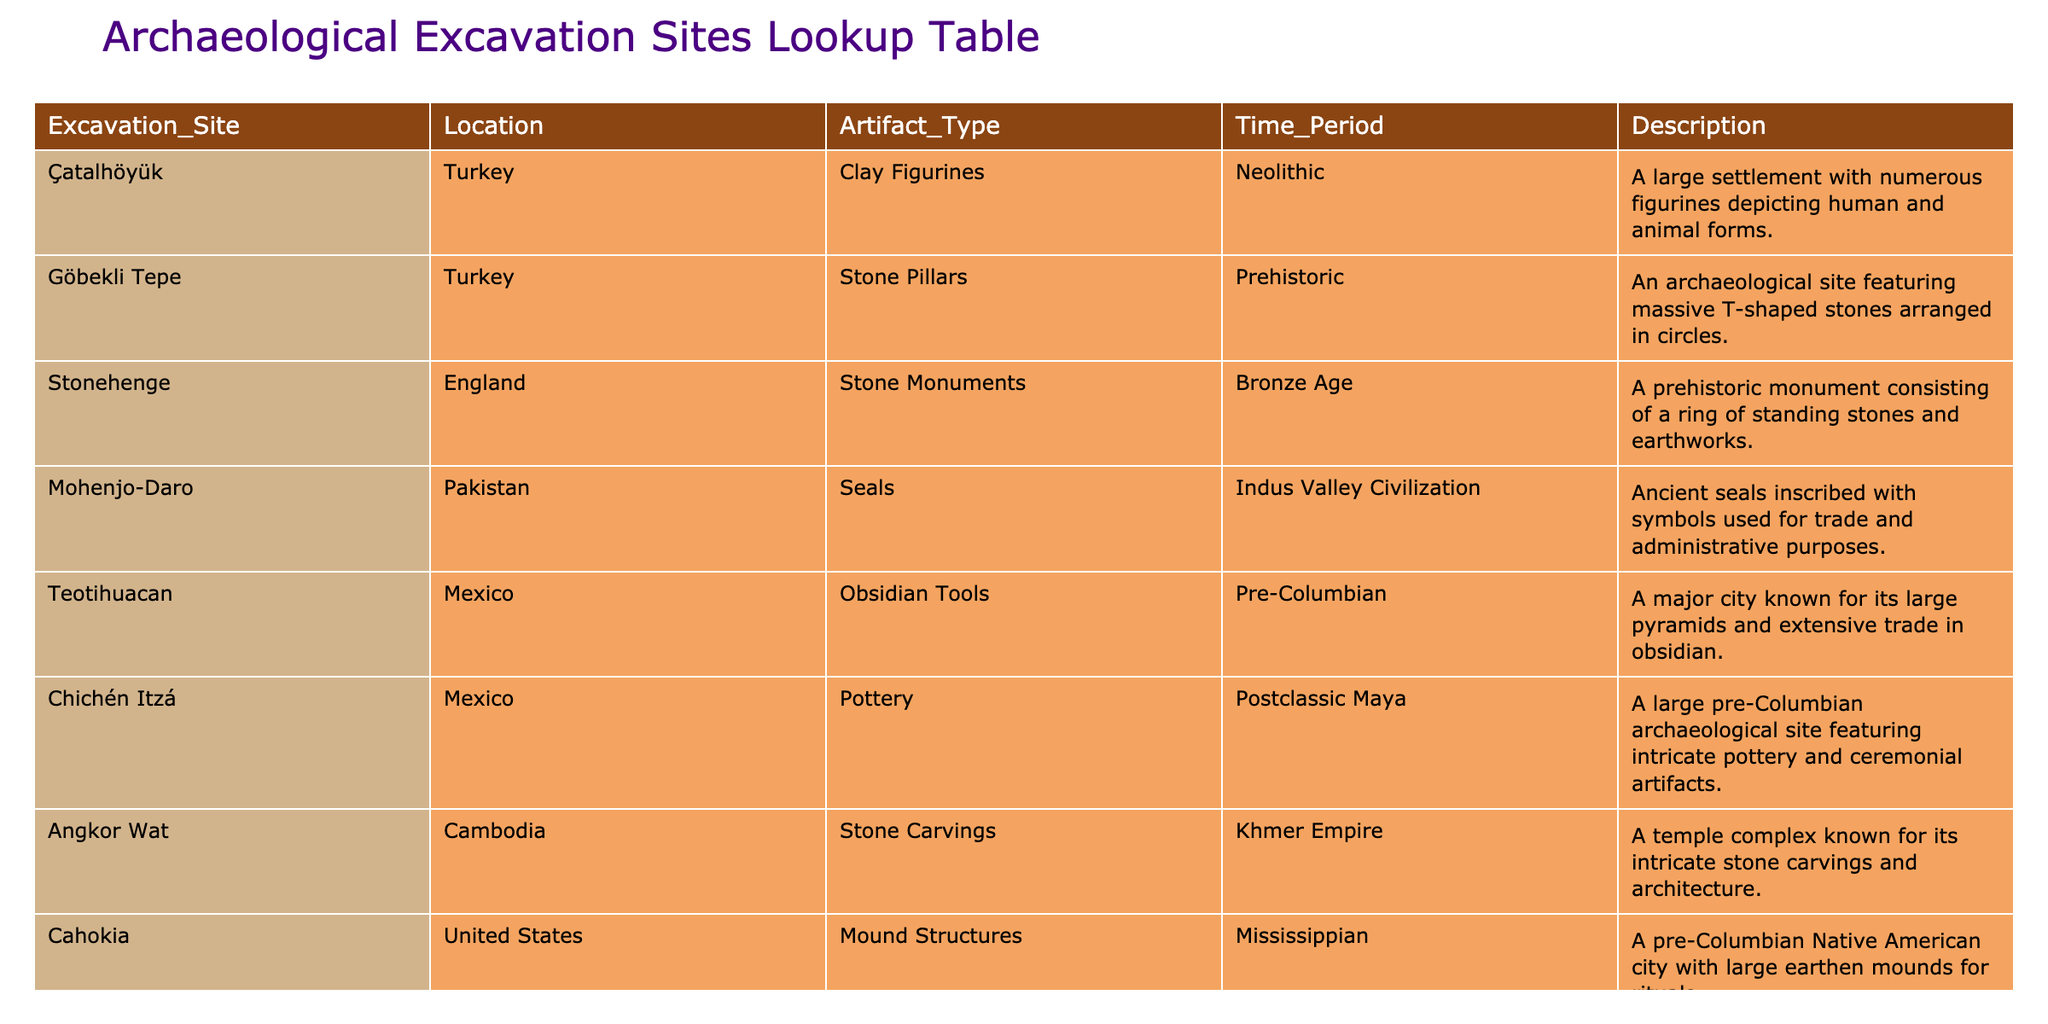What artifact type is found at Çatalhöyük? The table entry for Çatalhöyük indicates that the artifact type is Clay Figurines.
Answer: Clay Figurines Which location is associated with Stone Pillars? The table shows that Göbekli Tepe is the location associated with Stone Pillars.
Answer: Göbekli Tepe How many artifact types are listed for excavation sites in Mexico? The table lists two artifact types from Mexican excavation sites: Obsidian Tools at Teotihuacan and Pottery at Chichén Itzá. Therefore, the count is 2.
Answer: 2 True or False: Mesa Verde is known for its stone carvings. The table specifically states that Mesa Verde is known for Cliff Dwellings, not stone carvings. Therefore, the statement is false.
Answer: False What is the time period for artifacts found at Angkor Wat? According to the table, Angkor Wat's artifact type is from the Khmer Empire, indicating the corresponding time period.
Answer: Khmer Empire Which excavation site has the earliest time period indicated in the table? Göbekli Tepe is the earliest site listed, categorized as Prehistoric, whereas others fall into later periods like Neolithic, Bronze Age, etc.
Answer: Göbekli Tepe What type of artifacts can be found at Mohenjo-Daro? The table specifies that the artifacts from Mohenjo-Daro are Seals.
Answer: Seals What are the total number of excavation sites listed in the table that are situated in the United States? The table indicates two sites: Cahokia and Mesa Verde, both located in the United States, resulting in a total of 2 sites.
Answer: 2 Which artifact type is unique to the Indus Valley Civilization according to the table? The table shows that Seals are the artifact type unique to the Indus Valley Civilization, as no other site's artifacts belong to that period or type.
Answer: Seals 